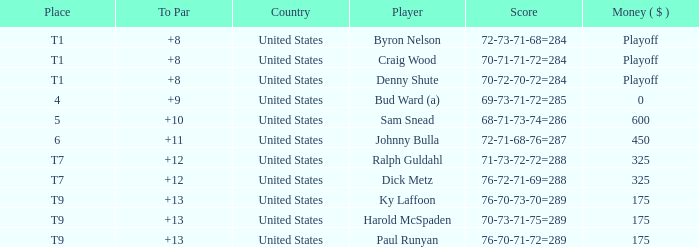What was the total To Par for Craig Wood? 8.0. 